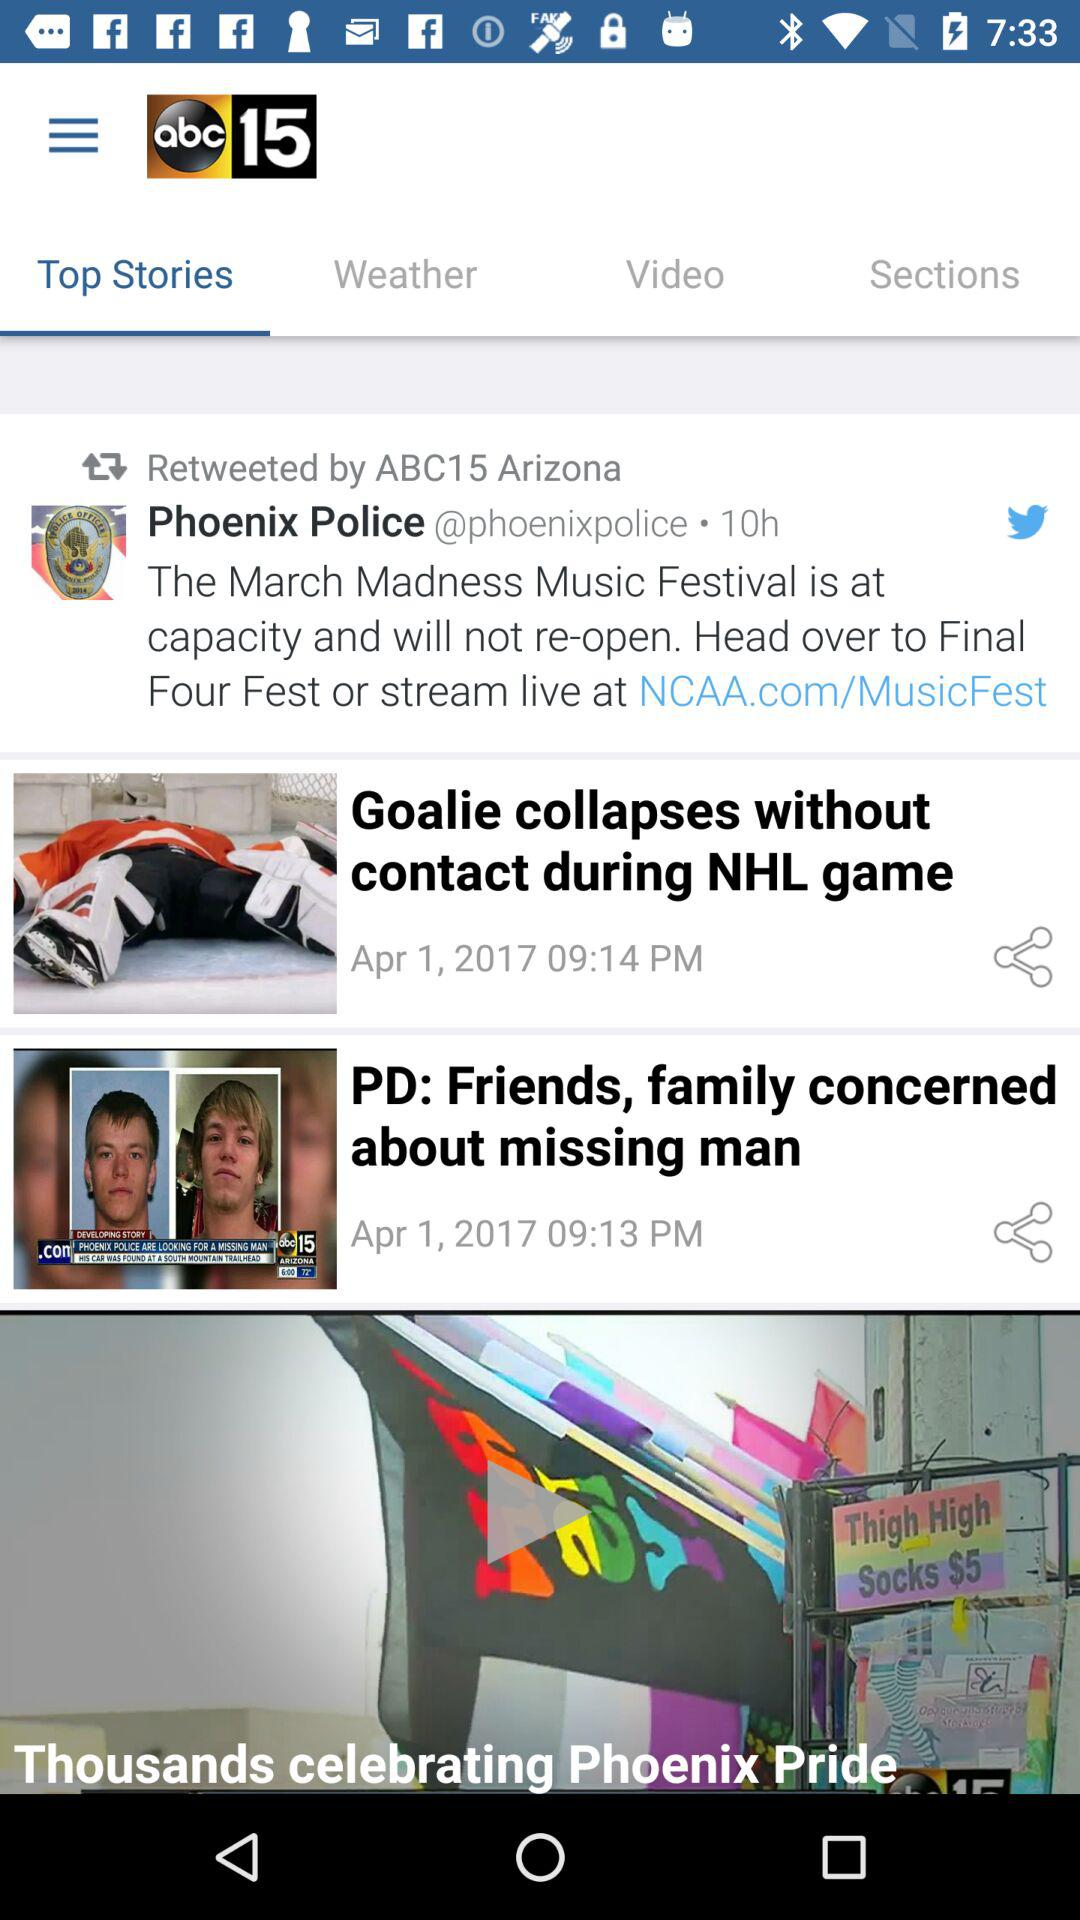How many hours ago did Phoenix Police upload the post? The post was uploaded 10 hours ago. 